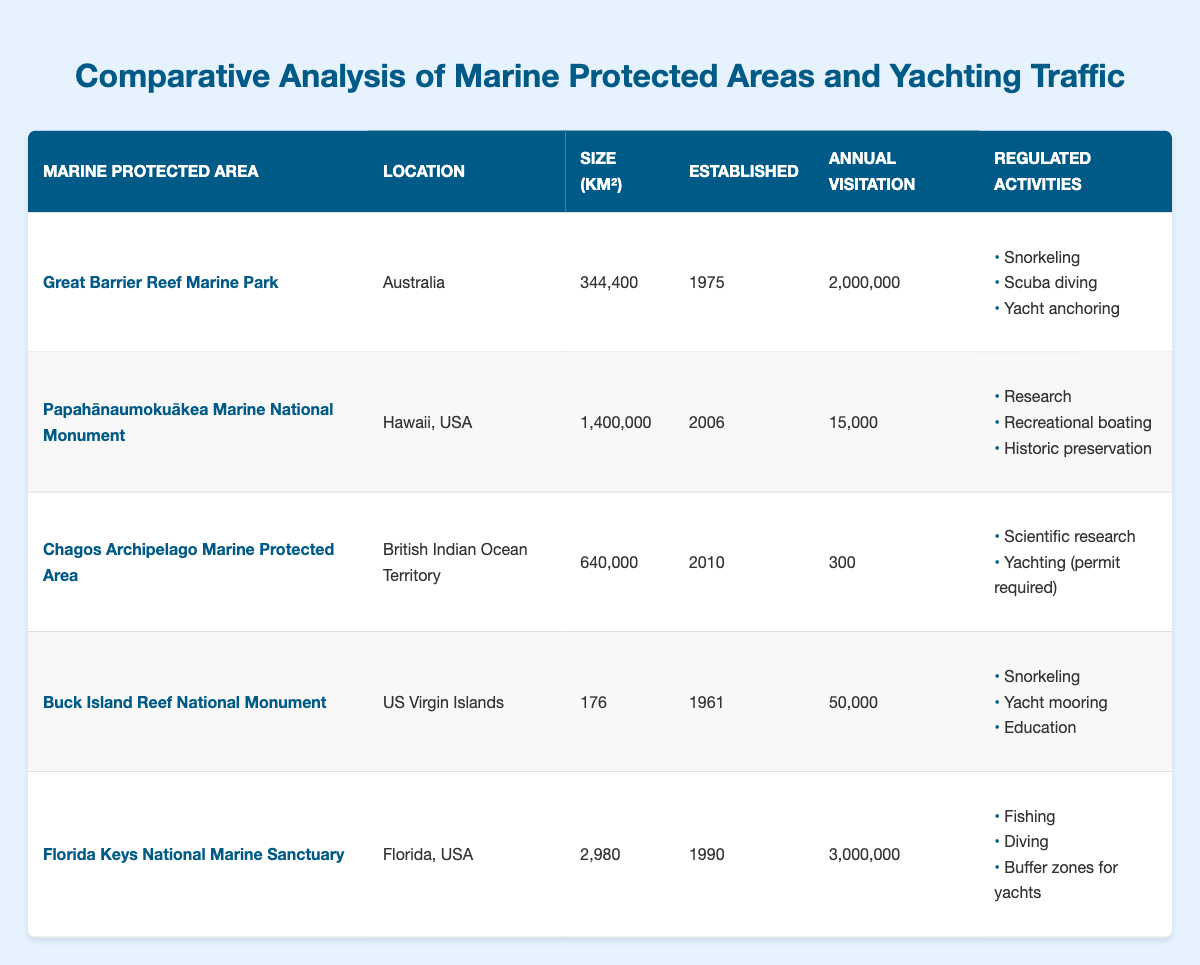What is the annual visitation for the Great Barrier Reef Marine Park? The annual visitation for the Great Barrier Reef Marine Park is clearly listed in the table under the "Annual Visitation" column for that specific Marine Protected Area, which states 2,000,000.
Answer: 2,000,000 Which Marine Protected Area has the largest size in square kilometers? By comparing the "Size (km²)" column for each Marine Protected Area, the Great Barrier Reef Marine Park is listed with 344,400 km², while the Papahānaumokuākea Marine National Monument has 1,400,000 km², meaning it is larger.
Answer: Papahānaumokuākea Marine National Monument Does the Buck Island Reef National Monument allow yacht anchoring? The "Regulated Activities" for Buck Island Reef National Monument do not list yacht anchoring; it mentions snorkeling, yacht mooring, and education. Therefore, it does not allow yacht anchoring.
Answer: No What is the difference in annual visitation between the Florida Keys National Marine Sanctuary and the Chagos Archipelago Marine Protected Area? The Florida Keys National Marine Sanctuary has an annual visitation of 3,000,000, while the Chagos Archipelago Marine Protected Area has 300. The difference is calculated as 3,000,000 - 300 = 2,999,700.
Answer: 2,999,700 How many Marine Protected Areas were established after 2000? By examining the "Established" column, only two Marine Protected Areas meet this requirement: the Papahānaumokuākea Marine National Monument (2006) and the Chagos Archipelago Marine Protected Area (2010). Therefore, the total is 2.
Answer: 2 What is the total annual visitation for all the Marine Protected Areas listed in the table? To find the total, sum the annual visitation for each area: 2,000,000 + 15,000 + 300 + 50,000 + 3,000,000 = 5,065,300.
Answer: 5,065,300 Which location has the most regulated activities associated with yachting? The Florida Keys National Marine Sanctuary has three regulated activities: fishing, diving, and buffer zones for yachts, which is more than other Marine Protected Areas listed.
Answer: Florida Keys National Marine Sanctuary Is there any Marine Protected Area that only allows yachting with a permit? In the data provided, the Chagos Archipelago Marine Protected Area specifies that yachting is allowed with a permit required, making it the only one with this condition.
Answer: Yes What is the average size of the Marine Protected Areas listed? To find the average size, sum the sizes: 344,400 + 1,400,000 + 640,000 + 176 + 2,980 = 2,387,556. Then divide by the number of areas (5): 2,387,556 / 5 = 477,511.2 km².
Answer: 477,511.2 km² Which Marine Protected Area was established first and what year was it? The marine area established first is Buck Island Reef National Monument in the year 1961, as indicated in the "Established" column.
Answer: Buck Island Reef National Monument, 1961 Are there any Marine Protected Areas that have annual visitation under 1,000? By reviewing the "Annual Visitation" column, Chagos Archipelago Marine Protected Area shows 300, which is under 1,000. Thus, there is at least one area that qualifies.
Answer: Yes 